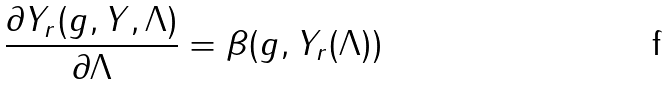Convert formula to latex. <formula><loc_0><loc_0><loc_500><loc_500>\frac { \partial Y _ { r } ( g , Y , \Lambda ) } { \partial \Lambda } = \beta ( g , Y _ { r } ( \Lambda ) )</formula> 